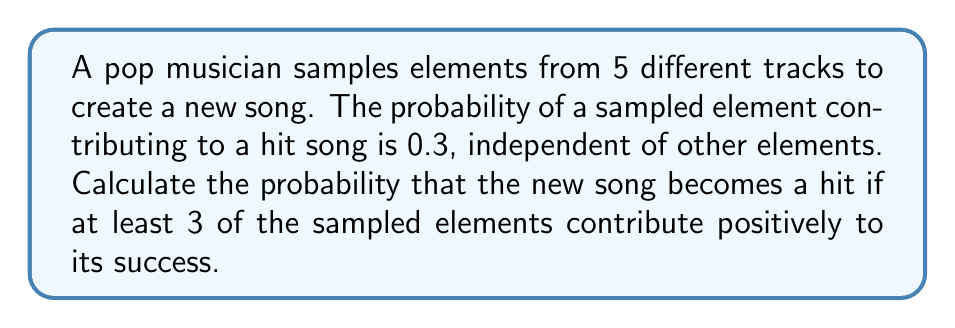Give your solution to this math problem. Let's approach this step-by-step:

1) This is a binomial probability problem. We have 5 independent trials (the 5 sampled elements), each with a success probability of 0.3.

2) We want the probability of at least 3 successes out of 5 trials. This means we need to calculate P(3 successes) + P(4 successes) + P(5 successes).

3) The binomial probability formula is:

   $$P(X = k) = \binom{n}{k} p^k (1-p)^{n-k}$$

   Where n is the number of trials, k is the number of successes, p is the probability of success on each trial.

4) Let's calculate each probability:

   For 3 successes: $$P(X = 3) = \binom{5}{3} (0.3)^3 (0.7)^2 = 10 \cdot 0.027 \cdot 0.49 = 0.1323$$
   
   For 4 successes: $$P(X = 4) = \binom{5}{4} (0.3)^4 (0.7)^1 = 5 \cdot 0.0081 \cdot 0.7 = 0.02835$$
   
   For 5 successes: $$P(X = 5) = \binom{5}{5} (0.3)^5 (0.7)^0 = 1 \cdot 0.00243 \cdot 1 = 0.00243$$

5) The total probability is the sum of these individual probabilities:

   $$P(X \geq 3) = 0.1323 + 0.02835 + 0.00243 = 0.16308$$
Answer: 0.16308 